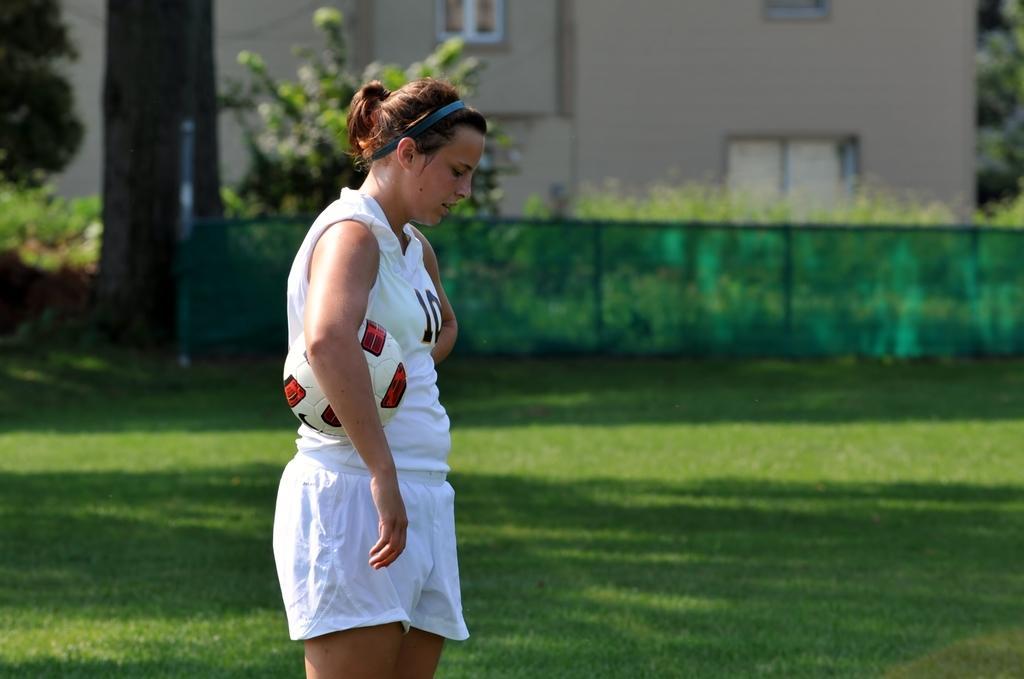How would you summarize this image in a sentence or two? In this image I can see the person standing on the ground. The person is wearing the white color dress and holding the ball. In the background I can see the railing and many trees. I can also see the building with windows. 